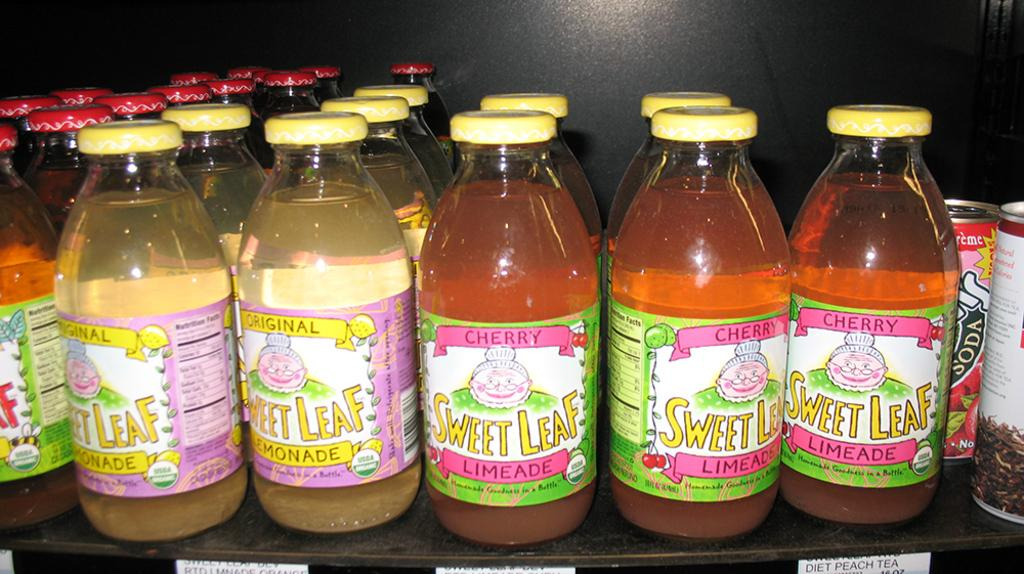Provide a one-sentence caption for the provided image. Bottles with Sweet Leaf Leaf Lemonade and Limeade with a round label that has USDA printed on it. 